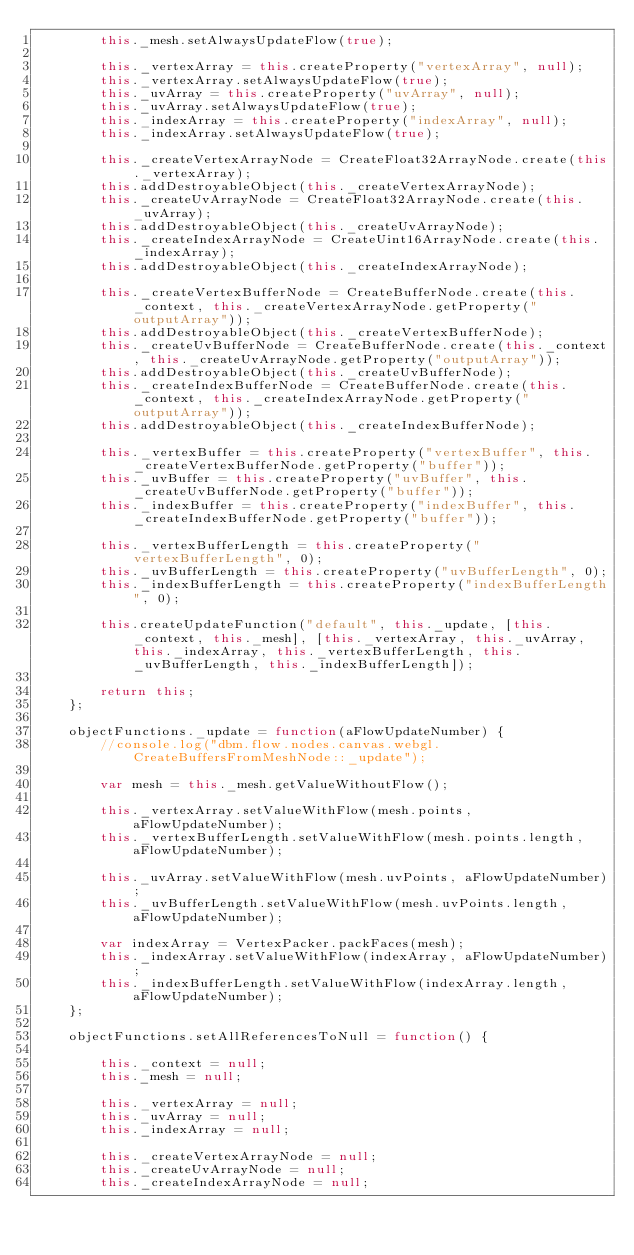Convert code to text. <code><loc_0><loc_0><loc_500><loc_500><_JavaScript_>		this._mesh.setAlwaysUpdateFlow(true);
		
		this._vertexArray = this.createProperty("vertexArray", null);
		this._vertexArray.setAlwaysUpdateFlow(true);
		this._uvArray = this.createProperty("uvArray", null);
		this._uvArray.setAlwaysUpdateFlow(true);
		this._indexArray = this.createProperty("indexArray", null);
		this._indexArray.setAlwaysUpdateFlow(true);
		
		this._createVertexArrayNode = CreateFloat32ArrayNode.create(this._vertexArray);
		this.addDestroyableObject(this._createVertexArrayNode);
		this._createUvArrayNode = CreateFloat32ArrayNode.create(this._uvArray);
		this.addDestroyableObject(this._createUvArrayNode);
		this._createIndexArrayNode = CreateUint16ArrayNode.create(this._indexArray);
		this.addDestroyableObject(this._createIndexArrayNode);
		
		this._createVertexBufferNode = CreateBufferNode.create(this._context, this._createVertexArrayNode.getProperty("outputArray"));
		this.addDestroyableObject(this._createVertexBufferNode);
		this._createUvBufferNode = CreateBufferNode.create(this._context, this._createUvArrayNode.getProperty("outputArray"));
		this.addDestroyableObject(this._createUvBufferNode);
		this._createIndexBufferNode = CreateBufferNode.create(this._context, this._createIndexArrayNode.getProperty("outputArray"));
		this.addDestroyableObject(this._createIndexBufferNode);
		
		this._vertexBuffer = this.createProperty("vertexBuffer", this._createVertexBufferNode.getProperty("buffer"));
		this._uvBuffer = this.createProperty("uvBuffer", this._createUvBufferNode.getProperty("buffer"));
		this._indexBuffer = this.createProperty("indexBuffer", this._createIndexBufferNode.getProperty("buffer"));
		
		this._vertexBufferLength = this.createProperty("vertexBufferLength", 0);
		this._uvBufferLength = this.createProperty("uvBufferLength", 0);
		this._indexBufferLength = this.createProperty("indexBufferLength", 0);
		
		this.createUpdateFunction("default", this._update, [this._context, this._mesh], [this._vertexArray, this._uvArray, this._indexArray, this._vertexBufferLength, this._uvBufferLength, this._indexBufferLength]);
		
		return this;
	};
	
	objectFunctions._update = function(aFlowUpdateNumber) {
		//console.log("dbm.flow.nodes.canvas.webgl.CreateBuffersFromMeshNode::_update");
		
		var mesh = this._mesh.getValueWithoutFlow();
		
		this._vertexArray.setValueWithFlow(mesh.points, aFlowUpdateNumber);
		this._vertexBufferLength.setValueWithFlow(mesh.points.length, aFlowUpdateNumber);
		
		this._uvArray.setValueWithFlow(mesh.uvPoints, aFlowUpdateNumber);
		this._uvBufferLength.setValueWithFlow(mesh.uvPoints.length, aFlowUpdateNumber);
		
		var indexArray = VertexPacker.packFaces(mesh);
		this._indexArray.setValueWithFlow(indexArray, aFlowUpdateNumber);
		this._indexBufferLength.setValueWithFlow(indexArray.length, aFlowUpdateNumber);
	};
	
	objectFunctions.setAllReferencesToNull = function() {
		
		this._context = null;
		this._mesh = null;
		
		this._vertexArray = null;
		this._uvArray = null;
		this._indexArray = null;
		
		this._createVertexArrayNode = null;
		this._createUvArrayNode = null;
		this._createIndexArrayNode = null;
		</code> 